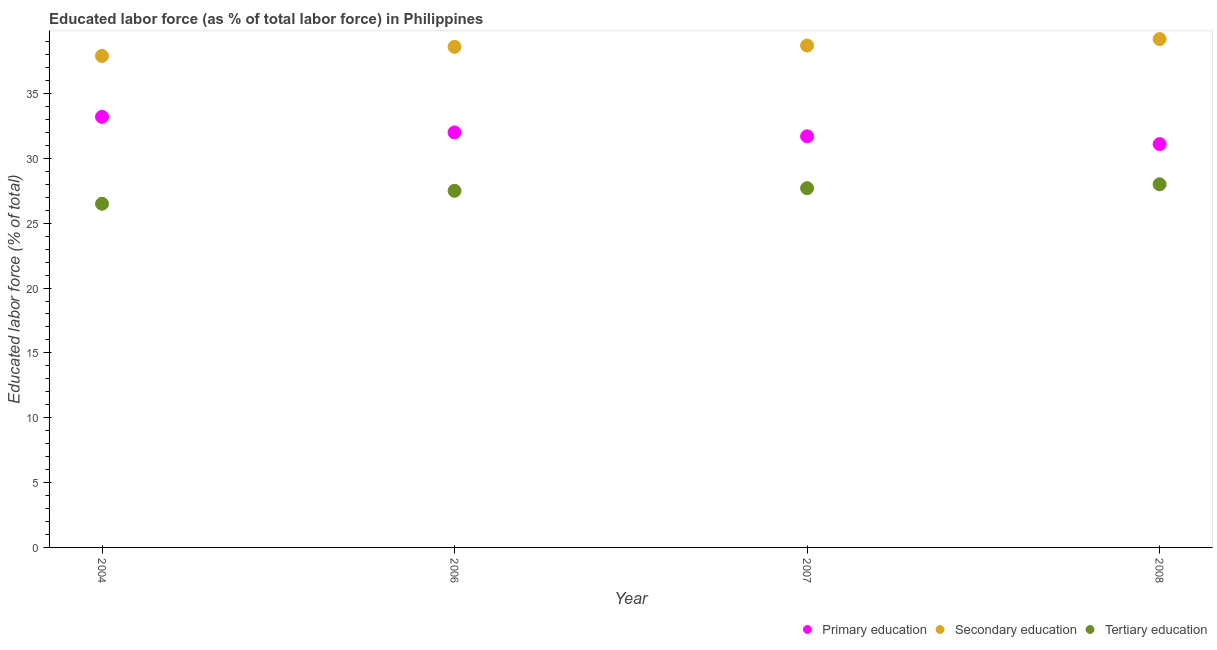How many different coloured dotlines are there?
Make the answer very short. 3. What is the percentage of labor force who received primary education in 2007?
Your answer should be very brief. 31.7. Across all years, what is the maximum percentage of labor force who received primary education?
Offer a very short reply. 33.2. In which year was the percentage of labor force who received primary education maximum?
Provide a succinct answer. 2004. In which year was the percentage of labor force who received primary education minimum?
Your response must be concise. 2008. What is the total percentage of labor force who received tertiary education in the graph?
Provide a short and direct response. 109.7. What is the difference between the percentage of labor force who received secondary education in 2004 and that in 2006?
Make the answer very short. -0.7. What is the difference between the percentage of labor force who received primary education in 2007 and the percentage of labor force who received secondary education in 2008?
Give a very brief answer. -7.5. What is the average percentage of labor force who received primary education per year?
Your answer should be compact. 32. In the year 2008, what is the difference between the percentage of labor force who received tertiary education and percentage of labor force who received secondary education?
Keep it short and to the point. -11.2. In how many years, is the percentage of labor force who received primary education greater than 22 %?
Your answer should be very brief. 4. What is the ratio of the percentage of labor force who received tertiary education in 2007 to that in 2008?
Ensure brevity in your answer.  0.99. Is the percentage of labor force who received secondary education in 2004 less than that in 2008?
Provide a short and direct response. Yes. Is the difference between the percentage of labor force who received secondary education in 2007 and 2008 greater than the difference between the percentage of labor force who received primary education in 2007 and 2008?
Offer a very short reply. No. What is the difference between the highest and the second highest percentage of labor force who received secondary education?
Provide a short and direct response. 0.5. What is the difference between the highest and the lowest percentage of labor force who received secondary education?
Ensure brevity in your answer.  1.3. In how many years, is the percentage of labor force who received primary education greater than the average percentage of labor force who received primary education taken over all years?
Offer a terse response. 1. Is it the case that in every year, the sum of the percentage of labor force who received primary education and percentage of labor force who received secondary education is greater than the percentage of labor force who received tertiary education?
Give a very brief answer. Yes. Does the percentage of labor force who received primary education monotonically increase over the years?
Your answer should be compact. No. Is the percentage of labor force who received secondary education strictly less than the percentage of labor force who received tertiary education over the years?
Offer a terse response. No. How many years are there in the graph?
Offer a terse response. 4. Does the graph contain any zero values?
Give a very brief answer. No. Does the graph contain grids?
Your response must be concise. No. What is the title of the graph?
Your answer should be compact. Educated labor force (as % of total labor force) in Philippines. Does "Ages 50+" appear as one of the legend labels in the graph?
Offer a terse response. No. What is the label or title of the Y-axis?
Keep it short and to the point. Educated labor force (% of total). What is the Educated labor force (% of total) of Primary education in 2004?
Provide a succinct answer. 33.2. What is the Educated labor force (% of total) in Secondary education in 2004?
Your answer should be very brief. 37.9. What is the Educated labor force (% of total) in Tertiary education in 2004?
Provide a short and direct response. 26.5. What is the Educated labor force (% of total) of Primary education in 2006?
Provide a succinct answer. 32. What is the Educated labor force (% of total) of Secondary education in 2006?
Ensure brevity in your answer.  38.6. What is the Educated labor force (% of total) of Primary education in 2007?
Offer a very short reply. 31.7. What is the Educated labor force (% of total) of Secondary education in 2007?
Your answer should be compact. 38.7. What is the Educated labor force (% of total) in Tertiary education in 2007?
Provide a short and direct response. 27.7. What is the Educated labor force (% of total) of Primary education in 2008?
Offer a very short reply. 31.1. What is the Educated labor force (% of total) in Secondary education in 2008?
Provide a short and direct response. 39.2. Across all years, what is the maximum Educated labor force (% of total) in Primary education?
Offer a very short reply. 33.2. Across all years, what is the maximum Educated labor force (% of total) in Secondary education?
Your answer should be very brief. 39.2. Across all years, what is the minimum Educated labor force (% of total) in Primary education?
Keep it short and to the point. 31.1. Across all years, what is the minimum Educated labor force (% of total) of Secondary education?
Offer a terse response. 37.9. Across all years, what is the minimum Educated labor force (% of total) of Tertiary education?
Your response must be concise. 26.5. What is the total Educated labor force (% of total) in Primary education in the graph?
Your answer should be compact. 128. What is the total Educated labor force (% of total) of Secondary education in the graph?
Your answer should be very brief. 154.4. What is the total Educated labor force (% of total) of Tertiary education in the graph?
Offer a terse response. 109.7. What is the difference between the Educated labor force (% of total) of Secondary education in 2004 and that in 2006?
Keep it short and to the point. -0.7. What is the difference between the Educated labor force (% of total) in Tertiary education in 2004 and that in 2006?
Provide a succinct answer. -1. What is the difference between the Educated labor force (% of total) in Primary education in 2004 and that in 2007?
Ensure brevity in your answer.  1.5. What is the difference between the Educated labor force (% of total) of Tertiary education in 2004 and that in 2008?
Make the answer very short. -1.5. What is the difference between the Educated labor force (% of total) of Primary education in 2006 and that in 2007?
Keep it short and to the point. 0.3. What is the difference between the Educated labor force (% of total) of Primary education in 2006 and that in 2008?
Provide a succinct answer. 0.9. What is the difference between the Educated labor force (% of total) in Tertiary education in 2006 and that in 2008?
Your answer should be very brief. -0.5. What is the difference between the Educated labor force (% of total) of Primary education in 2007 and that in 2008?
Provide a succinct answer. 0.6. What is the difference between the Educated labor force (% of total) of Secondary education in 2007 and that in 2008?
Your answer should be very brief. -0.5. What is the difference between the Educated labor force (% of total) of Primary education in 2004 and the Educated labor force (% of total) of Tertiary education in 2006?
Make the answer very short. 5.7. What is the difference between the Educated labor force (% of total) of Secondary education in 2004 and the Educated labor force (% of total) of Tertiary education in 2007?
Your answer should be compact. 10.2. What is the difference between the Educated labor force (% of total) of Primary education in 2004 and the Educated labor force (% of total) of Secondary education in 2008?
Your response must be concise. -6. What is the difference between the Educated labor force (% of total) of Primary education in 2004 and the Educated labor force (% of total) of Tertiary education in 2008?
Your response must be concise. 5.2. What is the difference between the Educated labor force (% of total) in Primary education in 2006 and the Educated labor force (% of total) in Secondary education in 2007?
Make the answer very short. -6.7. What is the difference between the Educated labor force (% of total) in Secondary education in 2006 and the Educated labor force (% of total) in Tertiary education in 2007?
Offer a very short reply. 10.9. What is the difference between the Educated labor force (% of total) in Secondary education in 2006 and the Educated labor force (% of total) in Tertiary education in 2008?
Provide a succinct answer. 10.6. What is the difference between the Educated labor force (% of total) of Secondary education in 2007 and the Educated labor force (% of total) of Tertiary education in 2008?
Your response must be concise. 10.7. What is the average Educated labor force (% of total) in Secondary education per year?
Give a very brief answer. 38.6. What is the average Educated labor force (% of total) in Tertiary education per year?
Keep it short and to the point. 27.43. In the year 2004, what is the difference between the Educated labor force (% of total) in Primary education and Educated labor force (% of total) in Secondary education?
Your answer should be very brief. -4.7. In the year 2004, what is the difference between the Educated labor force (% of total) in Secondary education and Educated labor force (% of total) in Tertiary education?
Your answer should be compact. 11.4. In the year 2006, what is the difference between the Educated labor force (% of total) in Primary education and Educated labor force (% of total) in Secondary education?
Offer a terse response. -6.6. In the year 2006, what is the difference between the Educated labor force (% of total) of Primary education and Educated labor force (% of total) of Tertiary education?
Give a very brief answer. 4.5. In the year 2007, what is the difference between the Educated labor force (% of total) in Primary education and Educated labor force (% of total) in Tertiary education?
Offer a very short reply. 4. In the year 2007, what is the difference between the Educated labor force (% of total) of Secondary education and Educated labor force (% of total) of Tertiary education?
Keep it short and to the point. 11. What is the ratio of the Educated labor force (% of total) in Primary education in 2004 to that in 2006?
Keep it short and to the point. 1.04. What is the ratio of the Educated labor force (% of total) of Secondary education in 2004 to that in 2006?
Keep it short and to the point. 0.98. What is the ratio of the Educated labor force (% of total) in Tertiary education in 2004 to that in 2006?
Offer a terse response. 0.96. What is the ratio of the Educated labor force (% of total) in Primary education in 2004 to that in 2007?
Provide a short and direct response. 1.05. What is the ratio of the Educated labor force (% of total) in Secondary education in 2004 to that in 2007?
Offer a very short reply. 0.98. What is the ratio of the Educated labor force (% of total) of Tertiary education in 2004 to that in 2007?
Your answer should be compact. 0.96. What is the ratio of the Educated labor force (% of total) of Primary education in 2004 to that in 2008?
Provide a short and direct response. 1.07. What is the ratio of the Educated labor force (% of total) of Secondary education in 2004 to that in 2008?
Give a very brief answer. 0.97. What is the ratio of the Educated labor force (% of total) in Tertiary education in 2004 to that in 2008?
Ensure brevity in your answer.  0.95. What is the ratio of the Educated labor force (% of total) in Primary education in 2006 to that in 2007?
Your answer should be compact. 1.01. What is the ratio of the Educated labor force (% of total) of Secondary education in 2006 to that in 2007?
Provide a short and direct response. 1. What is the ratio of the Educated labor force (% of total) of Primary education in 2006 to that in 2008?
Your answer should be compact. 1.03. What is the ratio of the Educated labor force (% of total) of Secondary education in 2006 to that in 2008?
Your response must be concise. 0.98. What is the ratio of the Educated labor force (% of total) in Tertiary education in 2006 to that in 2008?
Keep it short and to the point. 0.98. What is the ratio of the Educated labor force (% of total) of Primary education in 2007 to that in 2008?
Keep it short and to the point. 1.02. What is the ratio of the Educated labor force (% of total) of Secondary education in 2007 to that in 2008?
Keep it short and to the point. 0.99. What is the ratio of the Educated labor force (% of total) of Tertiary education in 2007 to that in 2008?
Provide a short and direct response. 0.99. What is the difference between the highest and the second highest Educated labor force (% of total) of Tertiary education?
Offer a very short reply. 0.3. What is the difference between the highest and the lowest Educated labor force (% of total) in Primary education?
Your answer should be very brief. 2.1. 